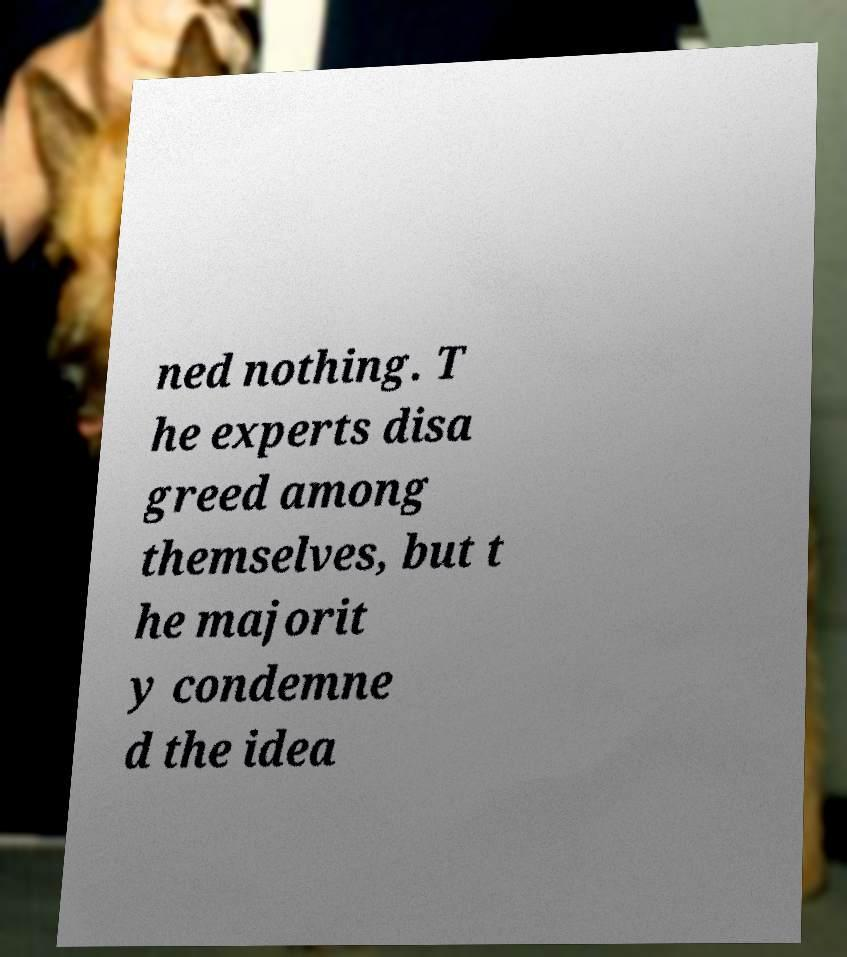What messages or text are displayed in this image? I need them in a readable, typed format. ned nothing. T he experts disa greed among themselves, but t he majorit y condemne d the idea 